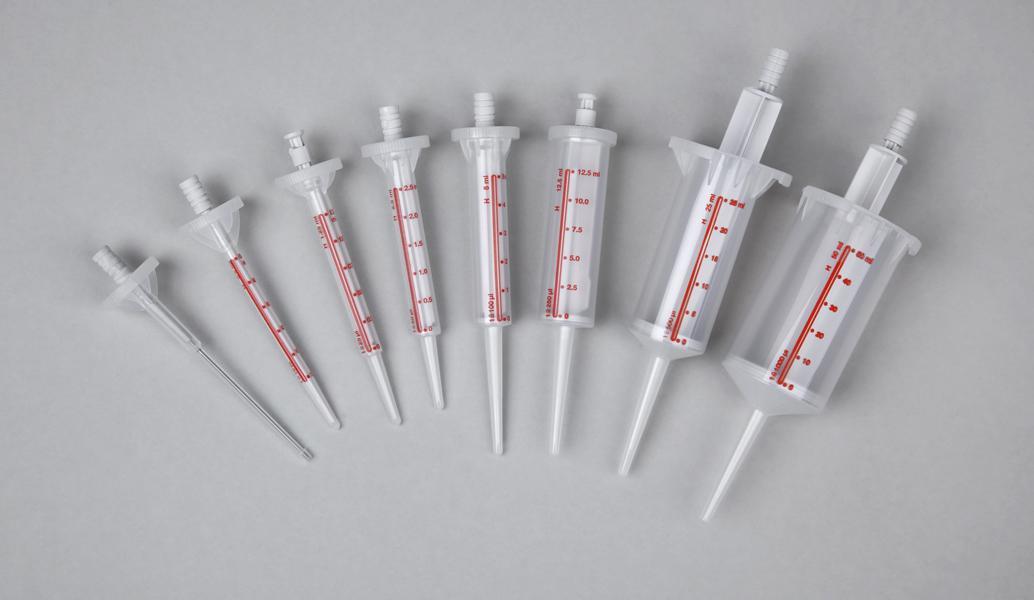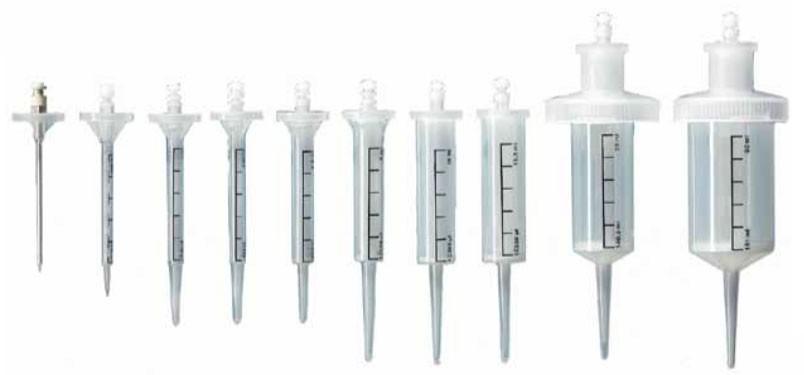The first image is the image on the left, the second image is the image on the right. Given the left and right images, does the statement "There are more needles in the right image." hold true? Answer yes or no. Yes. The first image is the image on the left, the second image is the image on the right. Evaluate the accuracy of this statement regarding the images: "There is a single syringe in one of the images and at least twice as many in the other.". Is it true? Answer yes or no. No. 